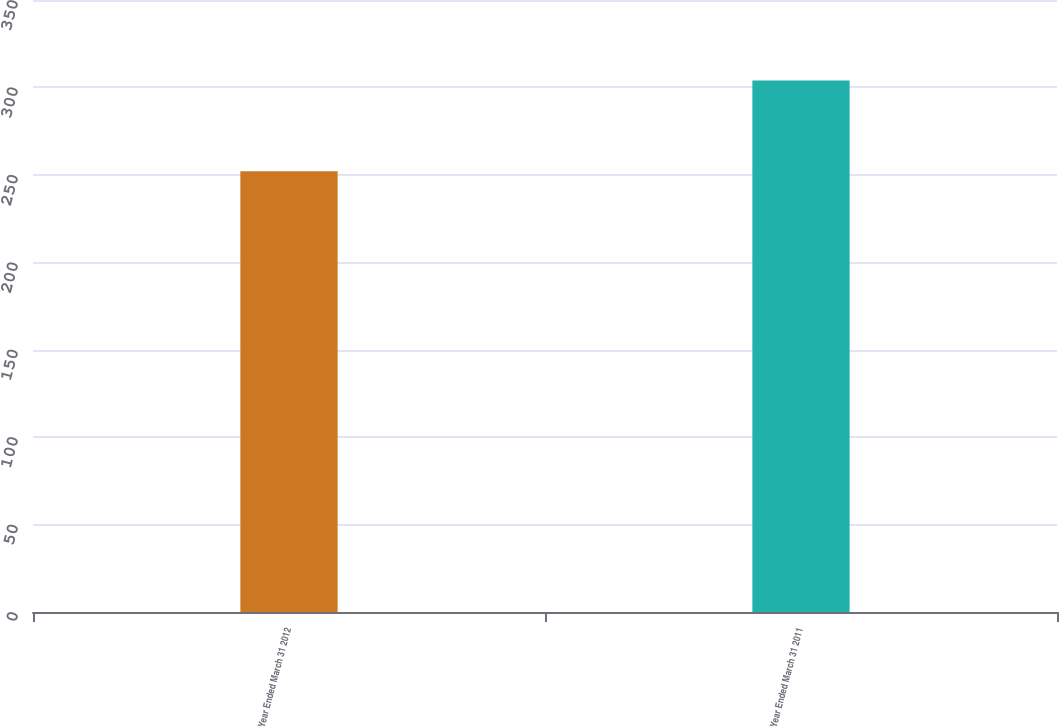Convert chart to OTSL. <chart><loc_0><loc_0><loc_500><loc_500><bar_chart><fcel>Year Ended March 31 2012<fcel>Year Ended March 31 2011<nl><fcel>252<fcel>304<nl></chart> 